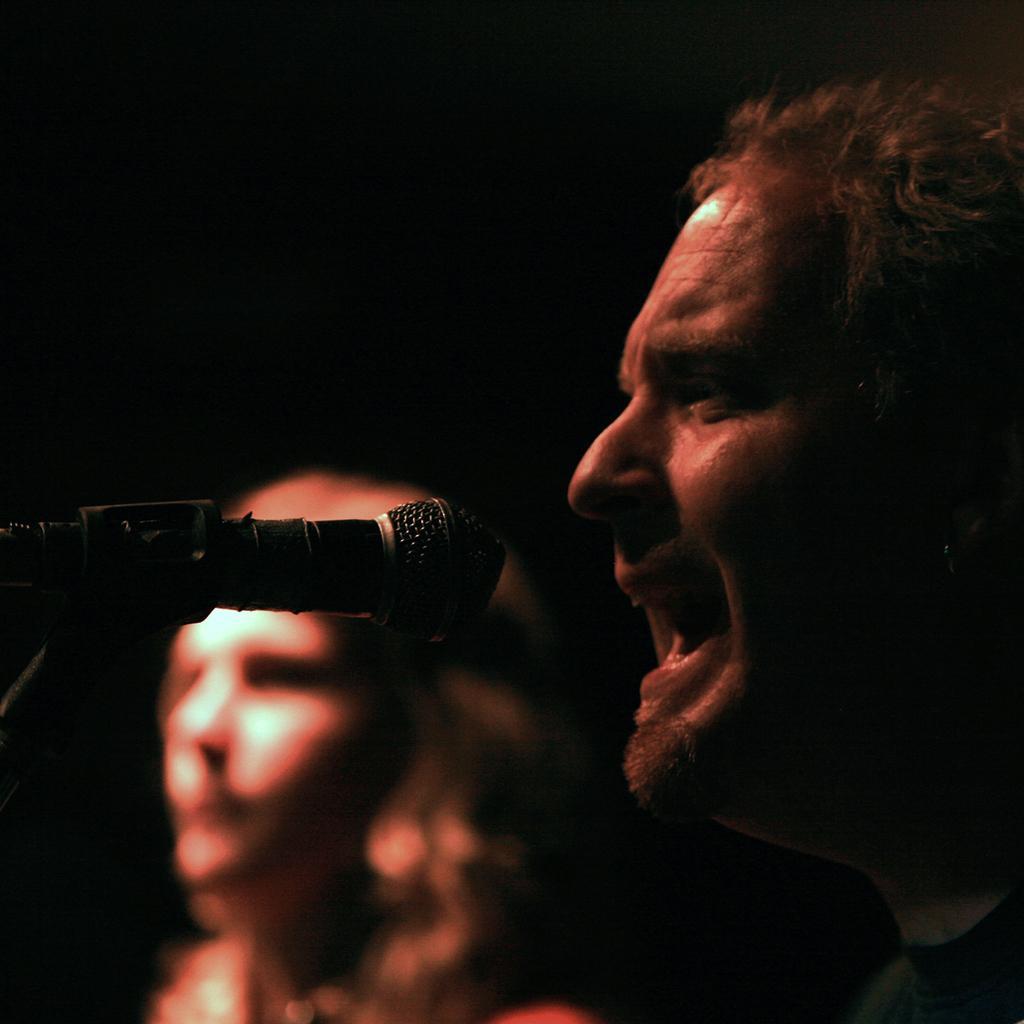Describe this image in one or two sentences. In the image in the center we can see two persons. In front of them,there is a microphone. 